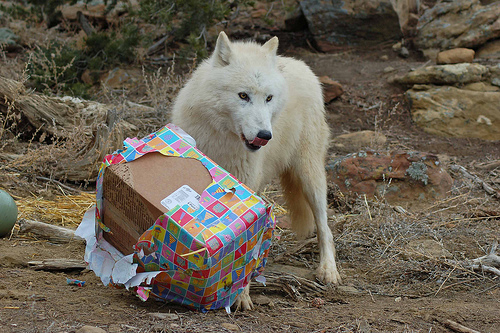<image>
Can you confirm if the present is in front of the wolf? Yes. The present is positioned in front of the wolf, appearing closer to the camera viewpoint. Where is the dog in relation to the box? Is it in front of the box? No. The dog is not in front of the box. The spatial positioning shows a different relationship between these objects. 